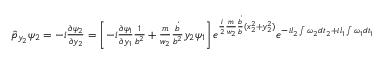<formula> <loc_0><loc_0><loc_500><loc_500>\begin{array} { r } { \hat { p } _ { y _ { 2 } } \psi _ { 2 } = - i \frac { \partial \psi _ { 2 } } { \partial y _ { 2 } } = \left [ - i \frac { \partial \psi _ { 1 } } { \partial y _ { 1 } } \frac { 1 } { b ^ { 2 } } + \frac { m } { w _ { 2 } } \frac { \dot { b } } { b ^ { 2 } } y _ { 2 } \psi _ { 1 } \right ] e ^ { \frac { i } { 2 } \frac { m } { w _ { 2 } } \frac { \dot { b } } { b } ( x _ { 2 } ^ { 2 } + y _ { 2 } ^ { 2 } ) } e ^ { - i l _ { 2 } \int \omega _ { 2 } d t _ { 2 } + i l _ { 1 } \int \omega _ { 1 } d t _ { 1 } } } \end{array}</formula> 